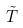<formula> <loc_0><loc_0><loc_500><loc_500>\tilde { T }</formula> 